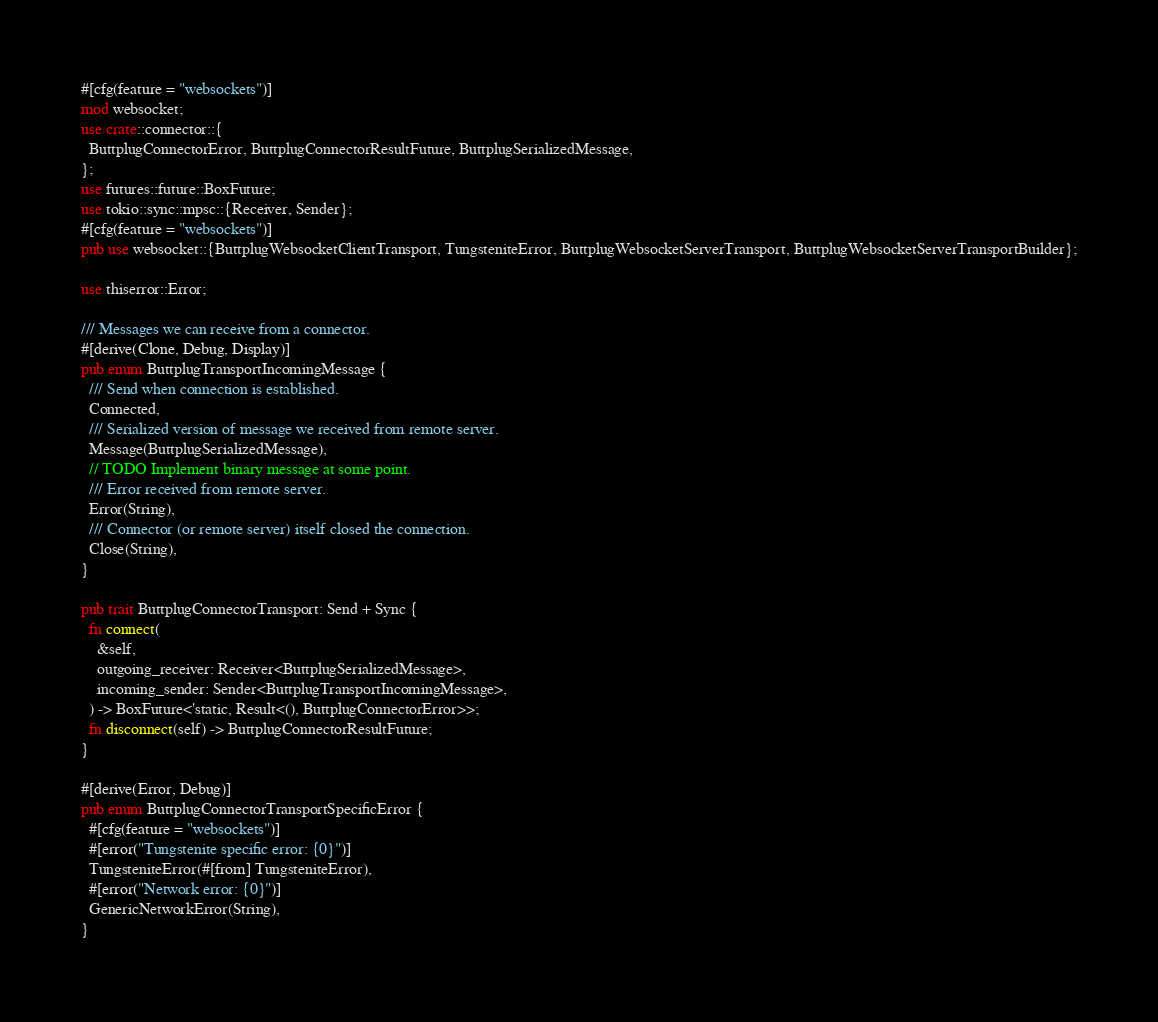Convert code to text. <code><loc_0><loc_0><loc_500><loc_500><_Rust_>#[cfg(feature = "websockets")]
mod websocket;
use crate::connector::{
  ButtplugConnectorError, ButtplugConnectorResultFuture, ButtplugSerializedMessage,
};
use futures::future::BoxFuture;
use tokio::sync::mpsc::{Receiver, Sender};
#[cfg(feature = "websockets")]
pub use websocket::{ButtplugWebsocketClientTransport, TungsteniteError, ButtplugWebsocketServerTransport, ButtplugWebsocketServerTransportBuilder};

use thiserror::Error;

/// Messages we can receive from a connector.
#[derive(Clone, Debug, Display)]
pub enum ButtplugTransportIncomingMessage {
  /// Send when connection is established.
  Connected,
  /// Serialized version of message we received from remote server.
  Message(ButtplugSerializedMessage),
  // TODO Implement binary message at some point.
  /// Error received from remote server.
  Error(String),
  /// Connector (or remote server) itself closed the connection.
  Close(String),
}

pub trait ButtplugConnectorTransport: Send + Sync {
  fn connect(
    &self,
    outgoing_receiver: Receiver<ButtplugSerializedMessage>,
    incoming_sender: Sender<ButtplugTransportIncomingMessage>,
  ) -> BoxFuture<'static, Result<(), ButtplugConnectorError>>;
  fn disconnect(self) -> ButtplugConnectorResultFuture;
}

#[derive(Error, Debug)]
pub enum ButtplugConnectorTransportSpecificError {
  #[cfg(feature = "websockets")]
  #[error("Tungstenite specific error: {0}")]
  TungsteniteError(#[from] TungsteniteError),
  #[error("Network error: {0}")]
  GenericNetworkError(String),
}
</code> 